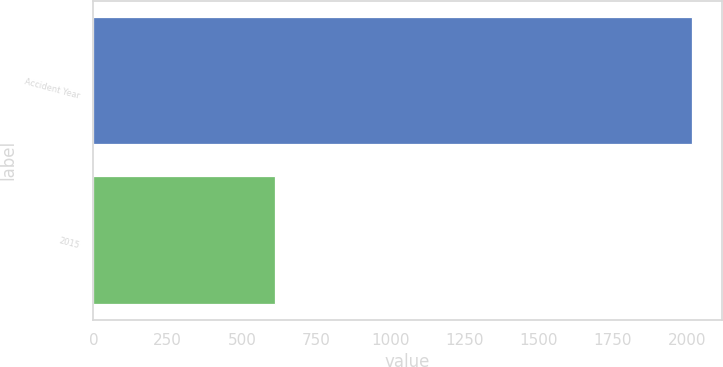Convert chart to OTSL. <chart><loc_0><loc_0><loc_500><loc_500><bar_chart><fcel>Accident Year<fcel>2015<nl><fcel>2015<fcel>610<nl></chart> 